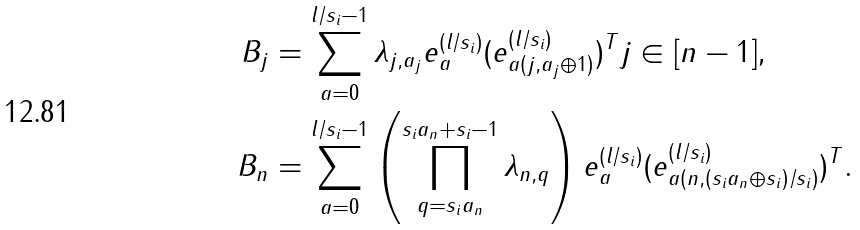Convert formula to latex. <formula><loc_0><loc_0><loc_500><loc_500>B _ { j } & = \sum _ { a = 0 } ^ { l / s _ { i } - 1 } \lambda _ { j , a _ { j } } e _ { a } ^ { ( l / s _ { i } ) } ( e _ { a ( j , a _ { j } \oplus 1 ) } ^ { ( l / s _ { i } ) } ) ^ { T } j \in [ n - 1 ] , \\ B _ { n } & = \sum _ { a = 0 } ^ { l / s _ { i } - 1 } \left ( \prod _ { q = s _ { i } a _ { n } } ^ { s _ { i } a _ { n } + s _ { i } - 1 } \lambda _ { n , q } \right ) e _ { a } ^ { ( l / s _ { i } ) } ( e _ { a ( n , ( s _ { i } a _ { n } \oplus s _ { i } ) / s _ { i } ) } ^ { ( l / s _ { i } ) } ) ^ { T } .</formula> 